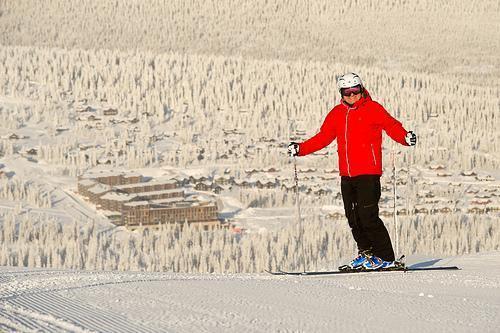How many people are swiming in water?
Give a very brief answer. 0. 